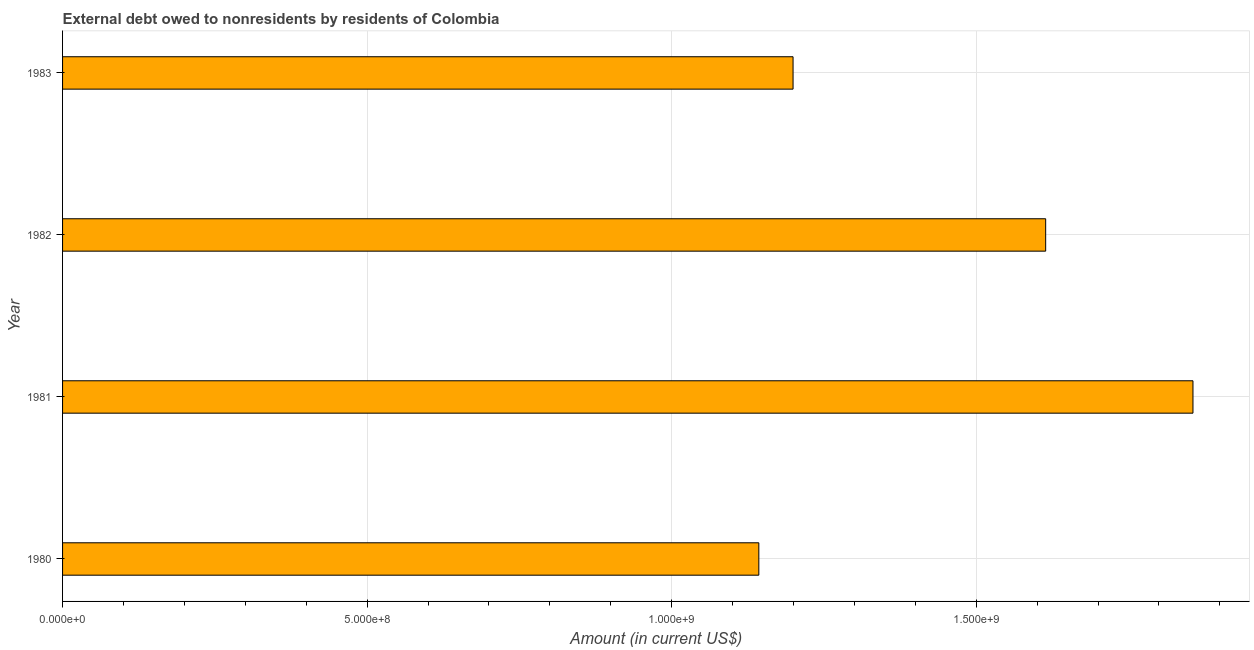What is the title of the graph?
Your answer should be compact. External debt owed to nonresidents by residents of Colombia. What is the label or title of the Y-axis?
Your answer should be very brief. Year. What is the debt in 1982?
Keep it short and to the point. 1.61e+09. Across all years, what is the maximum debt?
Make the answer very short. 1.86e+09. Across all years, what is the minimum debt?
Provide a short and direct response. 1.14e+09. In which year was the debt maximum?
Give a very brief answer. 1981. What is the sum of the debt?
Make the answer very short. 5.81e+09. What is the difference between the debt in 1980 and 1981?
Give a very brief answer. -7.13e+08. What is the average debt per year?
Keep it short and to the point. 1.45e+09. What is the median debt?
Your answer should be very brief. 1.41e+09. What is the ratio of the debt in 1980 to that in 1983?
Your response must be concise. 0.95. Is the debt in 1980 less than that in 1981?
Offer a terse response. Yes. Is the difference between the debt in 1982 and 1983 greater than the difference between any two years?
Offer a terse response. No. What is the difference between the highest and the second highest debt?
Offer a terse response. 2.42e+08. What is the difference between the highest and the lowest debt?
Your response must be concise. 7.13e+08. In how many years, is the debt greater than the average debt taken over all years?
Provide a succinct answer. 2. How many bars are there?
Offer a very short reply. 4. Are all the bars in the graph horizontal?
Your response must be concise. Yes. What is the difference between two consecutive major ticks on the X-axis?
Your response must be concise. 5.00e+08. What is the Amount (in current US$) in 1980?
Your response must be concise. 1.14e+09. What is the Amount (in current US$) in 1981?
Provide a succinct answer. 1.86e+09. What is the Amount (in current US$) in 1982?
Keep it short and to the point. 1.61e+09. What is the Amount (in current US$) of 1983?
Offer a very short reply. 1.20e+09. What is the difference between the Amount (in current US$) in 1980 and 1981?
Keep it short and to the point. -7.13e+08. What is the difference between the Amount (in current US$) in 1980 and 1982?
Provide a succinct answer. -4.71e+08. What is the difference between the Amount (in current US$) in 1980 and 1983?
Offer a terse response. -5.62e+07. What is the difference between the Amount (in current US$) in 1981 and 1982?
Provide a short and direct response. 2.42e+08. What is the difference between the Amount (in current US$) in 1981 and 1983?
Provide a succinct answer. 6.57e+08. What is the difference between the Amount (in current US$) in 1982 and 1983?
Offer a very short reply. 4.15e+08. What is the ratio of the Amount (in current US$) in 1980 to that in 1981?
Your response must be concise. 0.62. What is the ratio of the Amount (in current US$) in 1980 to that in 1982?
Ensure brevity in your answer.  0.71. What is the ratio of the Amount (in current US$) in 1980 to that in 1983?
Offer a terse response. 0.95. What is the ratio of the Amount (in current US$) in 1981 to that in 1982?
Keep it short and to the point. 1.15. What is the ratio of the Amount (in current US$) in 1981 to that in 1983?
Your response must be concise. 1.55. What is the ratio of the Amount (in current US$) in 1982 to that in 1983?
Offer a very short reply. 1.35. 